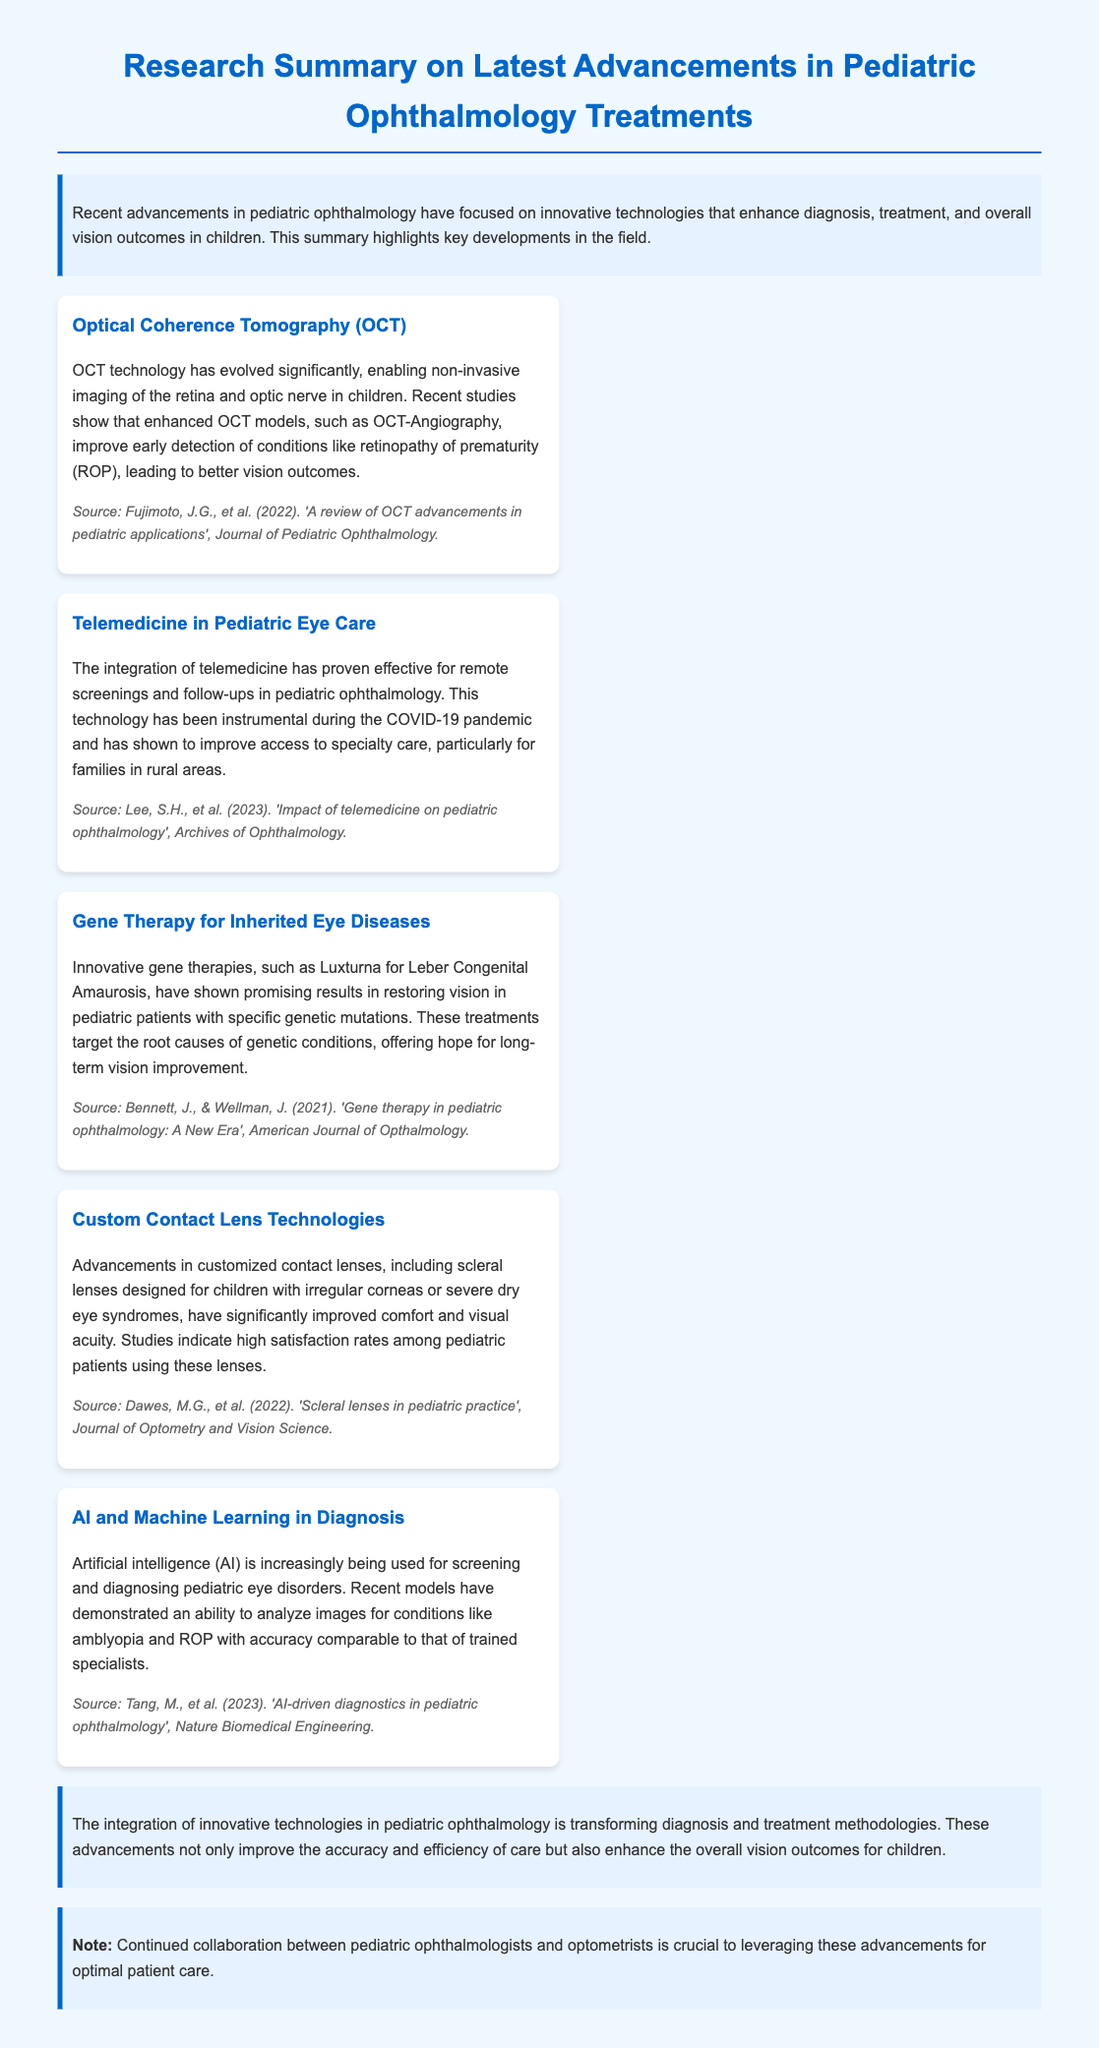What is the title of the document? The title of the document is stated at the top of the summary as "Research Summary on Latest Advancements in Pediatric Ophthalmology Treatments".
Answer: Research Summary on Latest Advancements in Pediatric Ophthalmology Treatments What technology has improved early detection of ROP? The document highlights Optical Coherence Tomography (OCT) technology as significantly improving early detection of conditions like retinopathy of prematurity (ROP).
Answer: Optical Coherence Tomography (OCT) Which innovative therapy is mentioned for inherited eye diseases? The summary discusses gene therapies, specifically mentioning Luxturna for Leber Congenital Amaurosis as an innovative therapy for inherited eye diseases.
Answer: Luxturna What role has telemedicine played during the COVID-19 pandemic? It has been instrumental for remote screenings and follow-ups, improving access to specialty care for families in rural areas.
Answer: Remote screenings and follow-ups Which advancement has shown high satisfaction rates among pediatric patients? Customized contact lenses, particularly scleral lenses for irregular corneas or severe dry eye syndromes, have shown high satisfaction rates.
Answer: Customized contact lenses How is AI utilized in pediatric ophthalmology? AI is used for screening and diagnosing pediatric eye disorders, with recent models demonstrating comparable accuracy to trained specialists.
Answer: Screening and diagnosing What is necessary for leveraging advancements in pediatric ophthalmology? Continued collaboration between pediatric ophthalmologists and optometrists is necessary to leverage these advancements effectively.
Answer: Collaboration between pediatric ophthalmologists and optometrists What was the source for the information on telemedicine? The document cites the source as Lee, S.H., et al. (2023).
Answer: Lee, S.H., et al. (2023) 